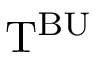Convert formula to latex. <formula><loc_0><loc_0><loc_500><loc_500>T ^ { B U }</formula> 